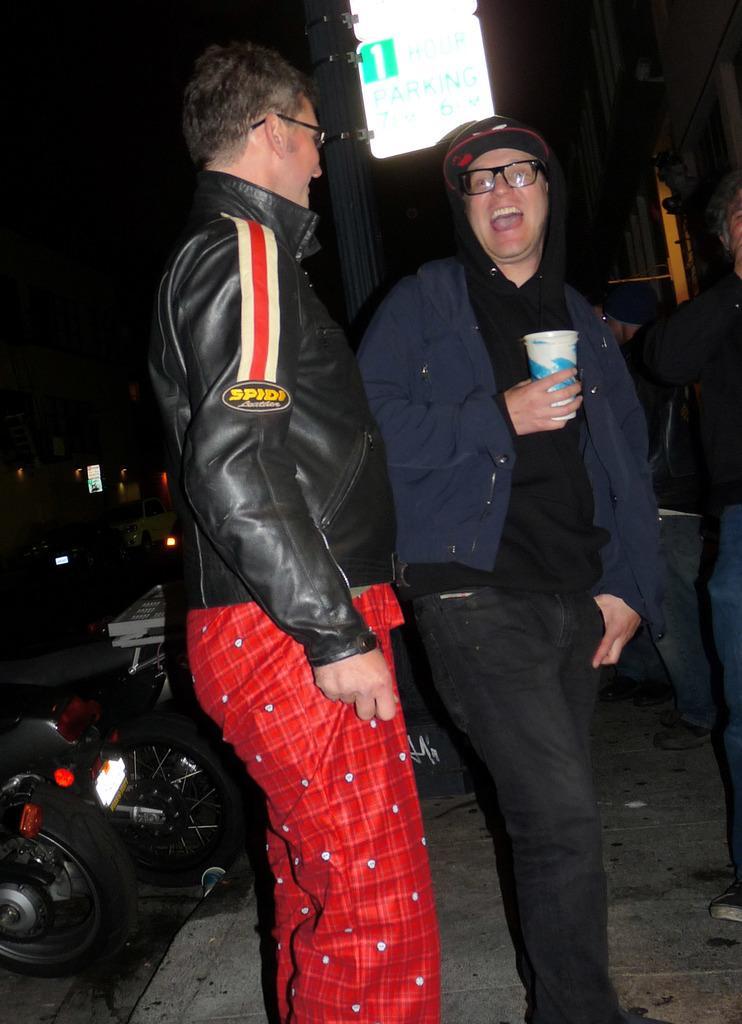In one or two sentences, can you explain what this image depicts? In this image I can see two persons standing, the person at right is wearing blue and black color dress and the person at left is wearing black and red color dress. Background I can see few vehicles and I can also see a light board and the sky is in black color. 